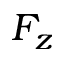<formula> <loc_0><loc_0><loc_500><loc_500>F _ { z }</formula> 